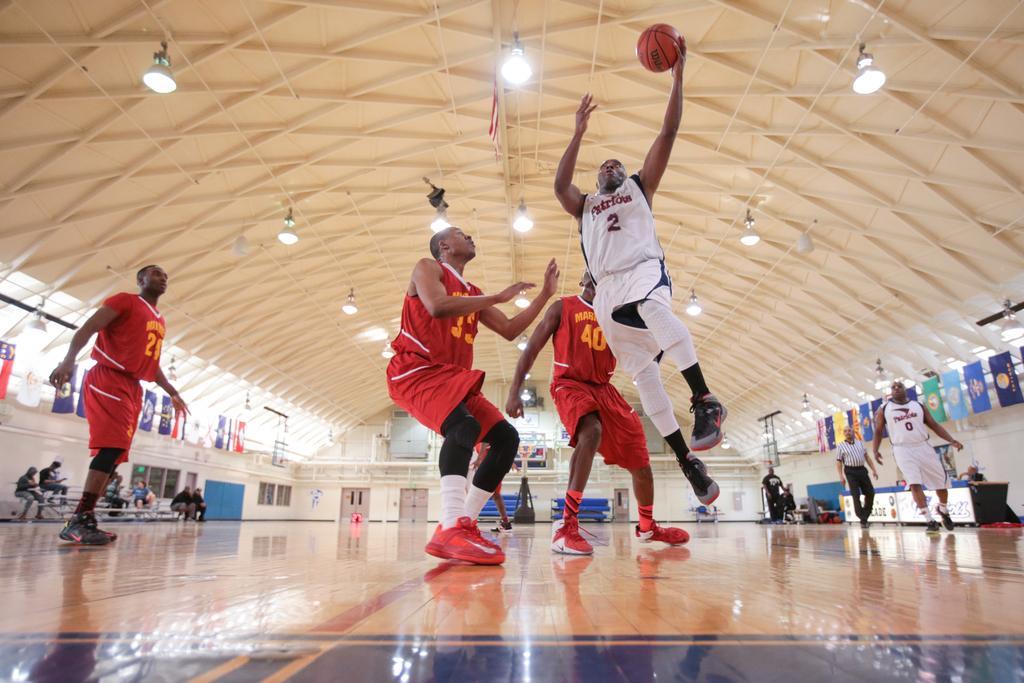Can you describe this image briefly? In this image we can see group of persons wearing dress are standing on the floor. On the left side of the image we can see a group of people sitting on benches. To the right side of the image we can see a table, sign boards with text. In the background, we can see some flags, group of doors and windows, goal post and some lights. 